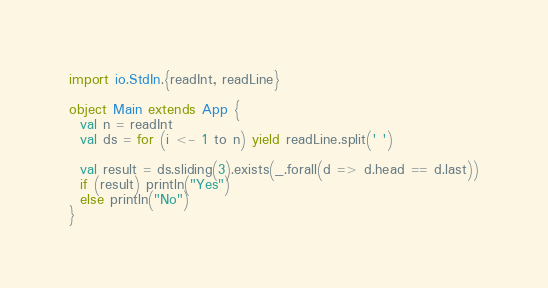<code> <loc_0><loc_0><loc_500><loc_500><_Scala_>import io.StdIn.{readInt, readLine}

object Main extends App {
  val n = readInt
  val ds = for (i <- 1 to n) yield readLine.split(' ')

  val result = ds.sliding(3).exists(_.forall(d => d.head == d.last))
  if (result) println("Yes")
  else println("No")
}</code> 